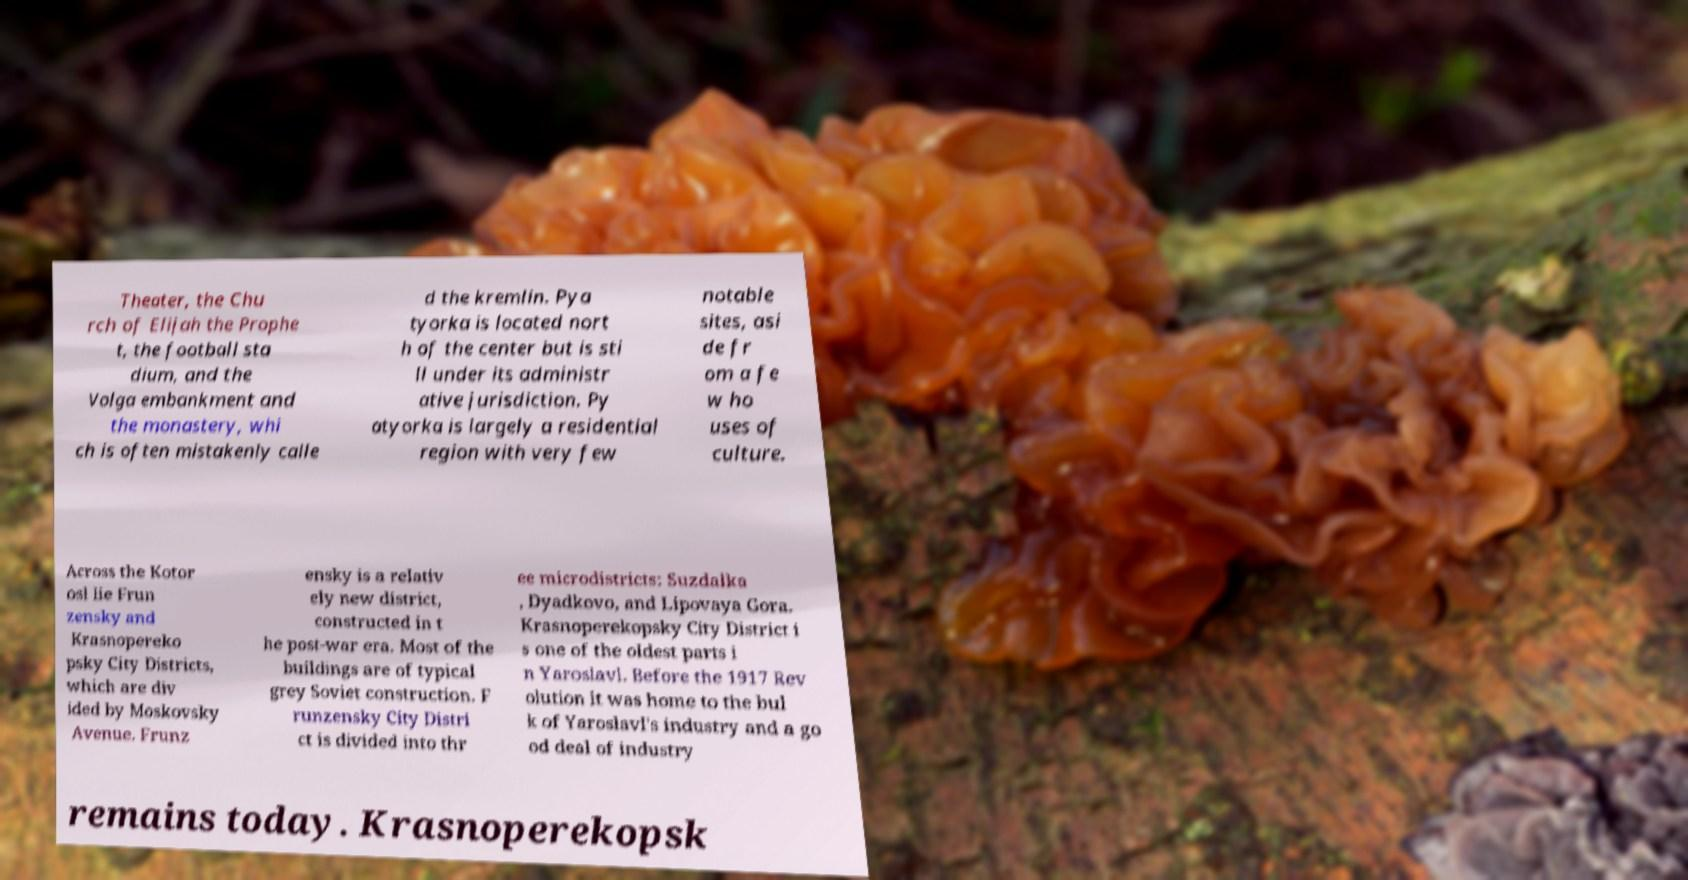There's text embedded in this image that I need extracted. Can you transcribe it verbatim? Theater, the Chu rch of Elijah the Prophe t, the football sta dium, and the Volga embankment and the monastery, whi ch is often mistakenly calle d the kremlin. Pya tyorka is located nort h of the center but is sti ll under its administr ative jurisdiction. Py atyorka is largely a residential region with very few notable sites, asi de fr om a fe w ho uses of culture. Across the Kotor osl lie Frun zensky and Krasnopereko psky City Districts, which are div ided by Moskovsky Avenue. Frunz ensky is a relativ ely new district, constructed in t he post-war era. Most of the buildings are of typical grey Soviet construction. F runzensky City Distri ct is divided into thr ee microdistricts: Suzdalka , Dyadkovo, and Lipovaya Gora. Krasnoperekopsky City District i s one of the oldest parts i n Yaroslavl. Before the 1917 Rev olution it was home to the bul k of Yaroslavl's industry and a go od deal of industry remains today. Krasnoperekopsk 